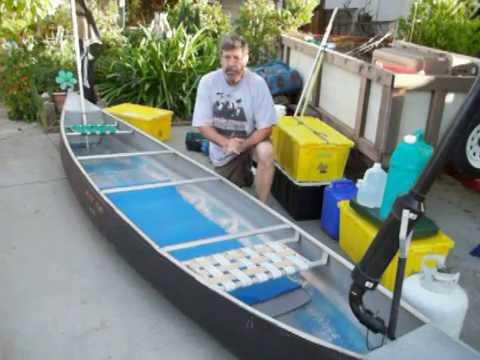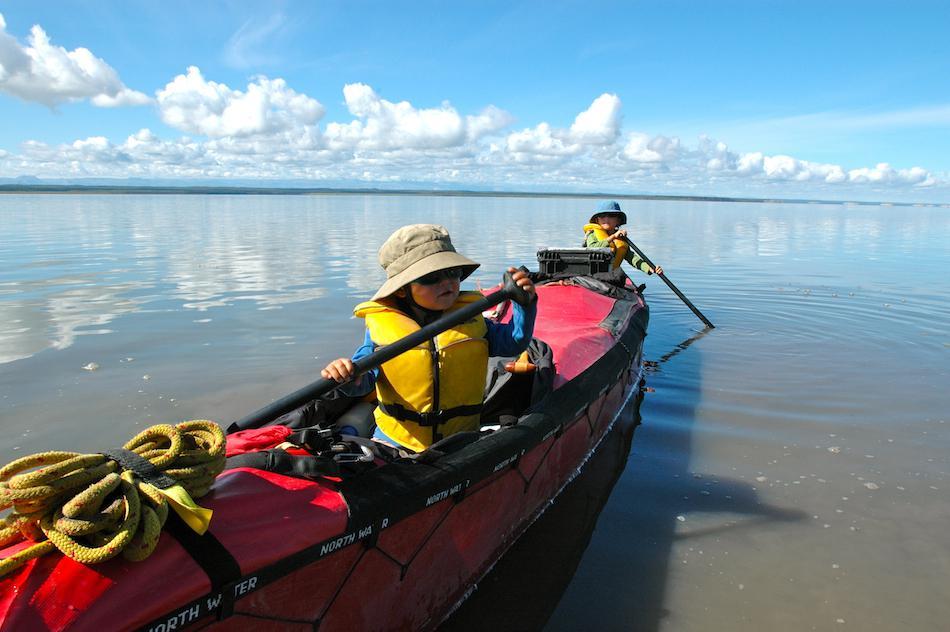The first image is the image on the left, the second image is the image on the right. For the images displayed, is the sentence "All boats are pictured in an area with water and full of gear, but no boats have a person inside." factually correct? Answer yes or no. No. The first image is the image on the left, the second image is the image on the right. Examine the images to the left and right. Is the description "The right image includes one red canoe." accurate? Answer yes or no. Yes. 